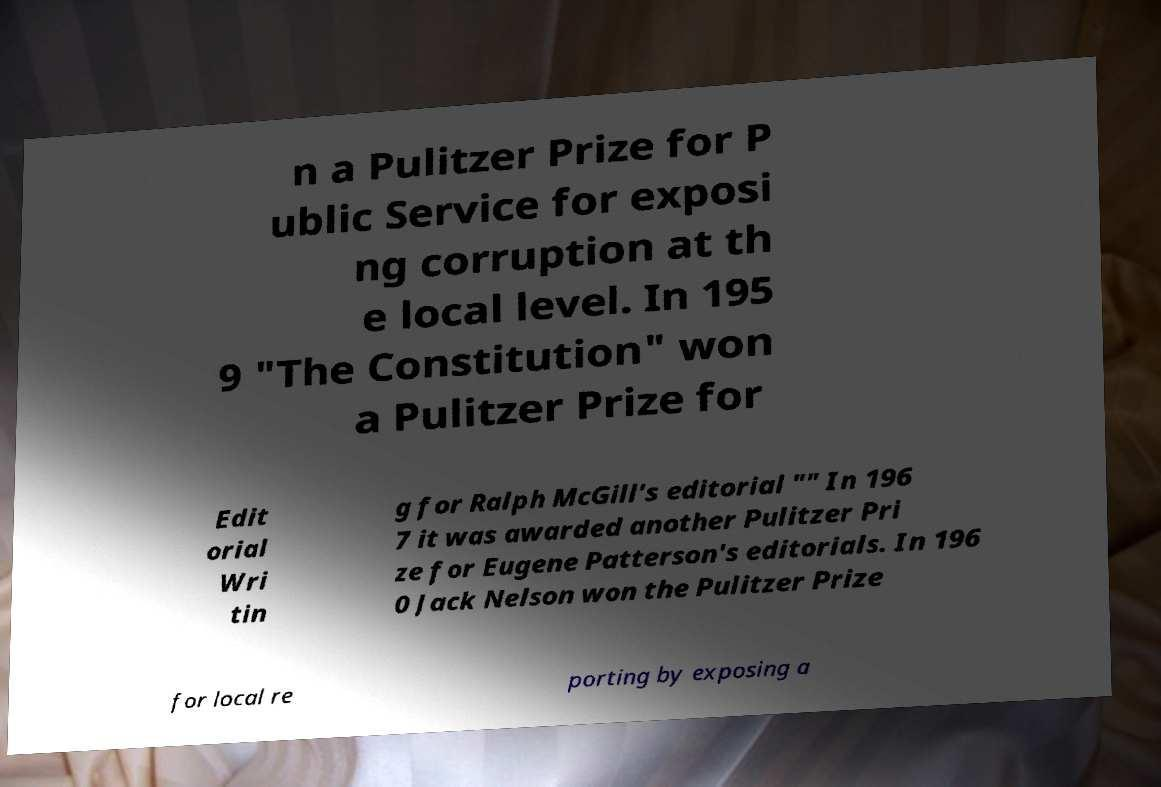Could you assist in decoding the text presented in this image and type it out clearly? n a Pulitzer Prize for P ublic Service for exposi ng corruption at th e local level. In 195 9 "The Constitution" won a Pulitzer Prize for Edit orial Wri tin g for Ralph McGill's editorial "" In 196 7 it was awarded another Pulitzer Pri ze for Eugene Patterson's editorials. In 196 0 Jack Nelson won the Pulitzer Prize for local re porting by exposing a 